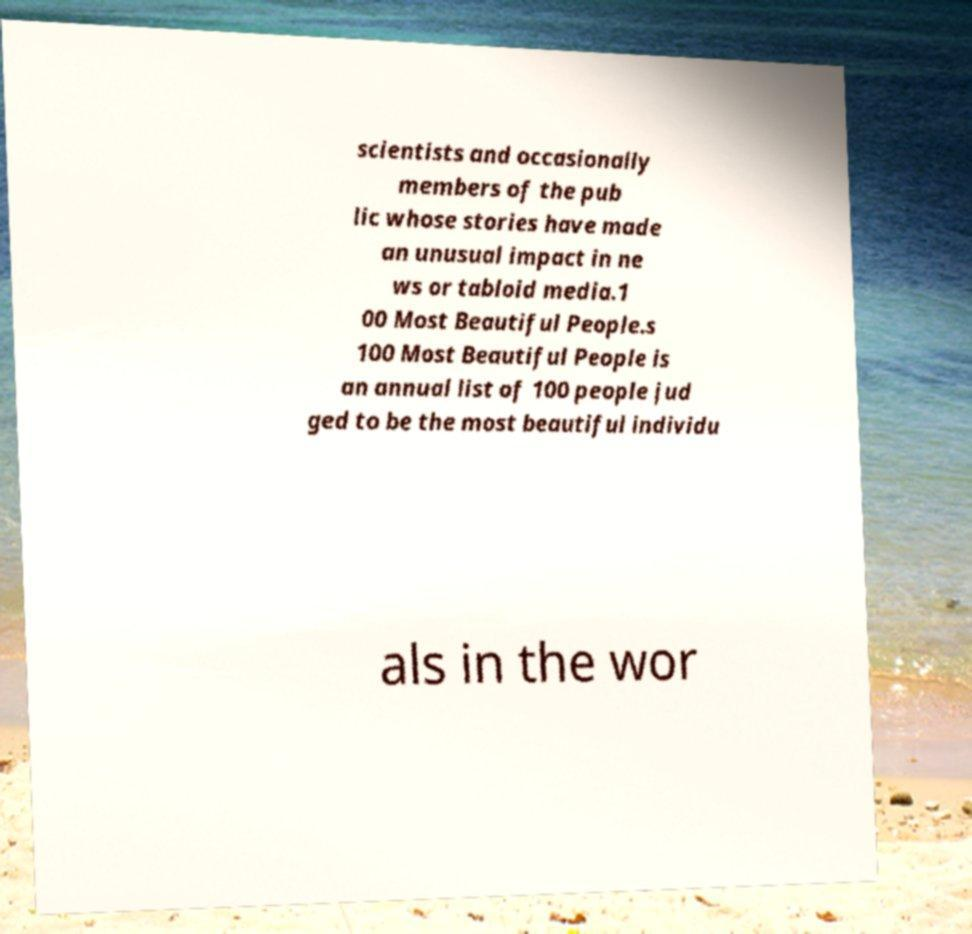Could you assist in decoding the text presented in this image and type it out clearly? scientists and occasionally members of the pub lic whose stories have made an unusual impact in ne ws or tabloid media.1 00 Most Beautiful People.s 100 Most Beautiful People is an annual list of 100 people jud ged to be the most beautiful individu als in the wor 